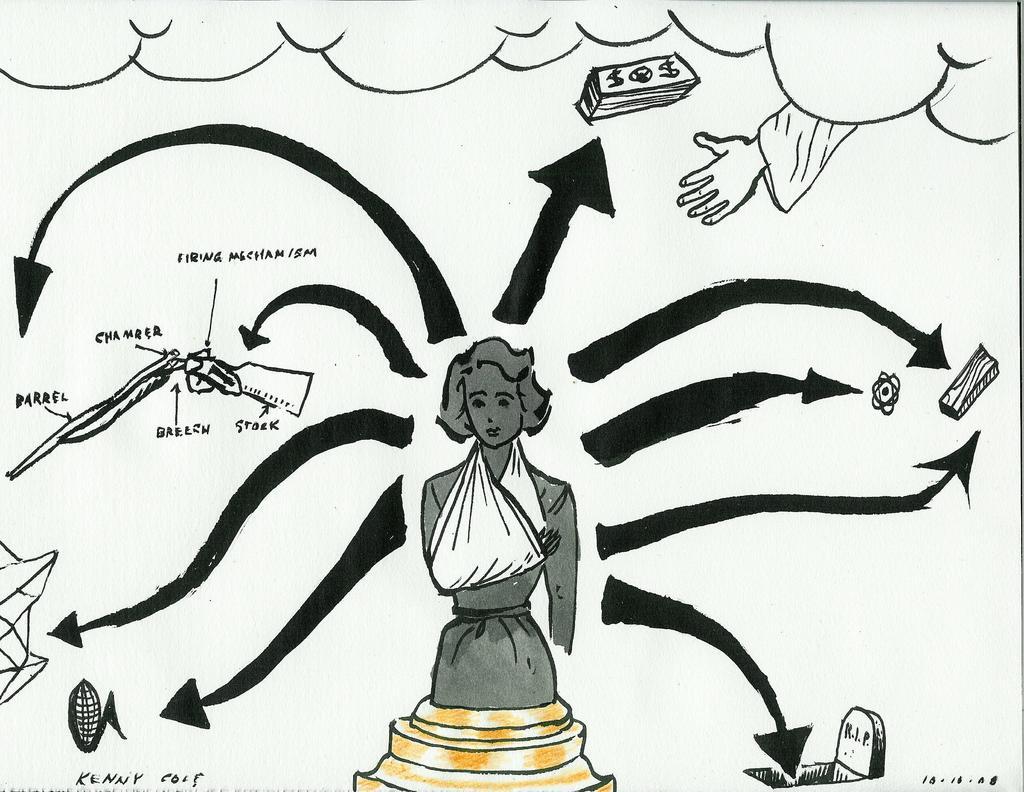Please provide a concise description of this image. This is a drawing of a lady. There are arrows and also something is written. 